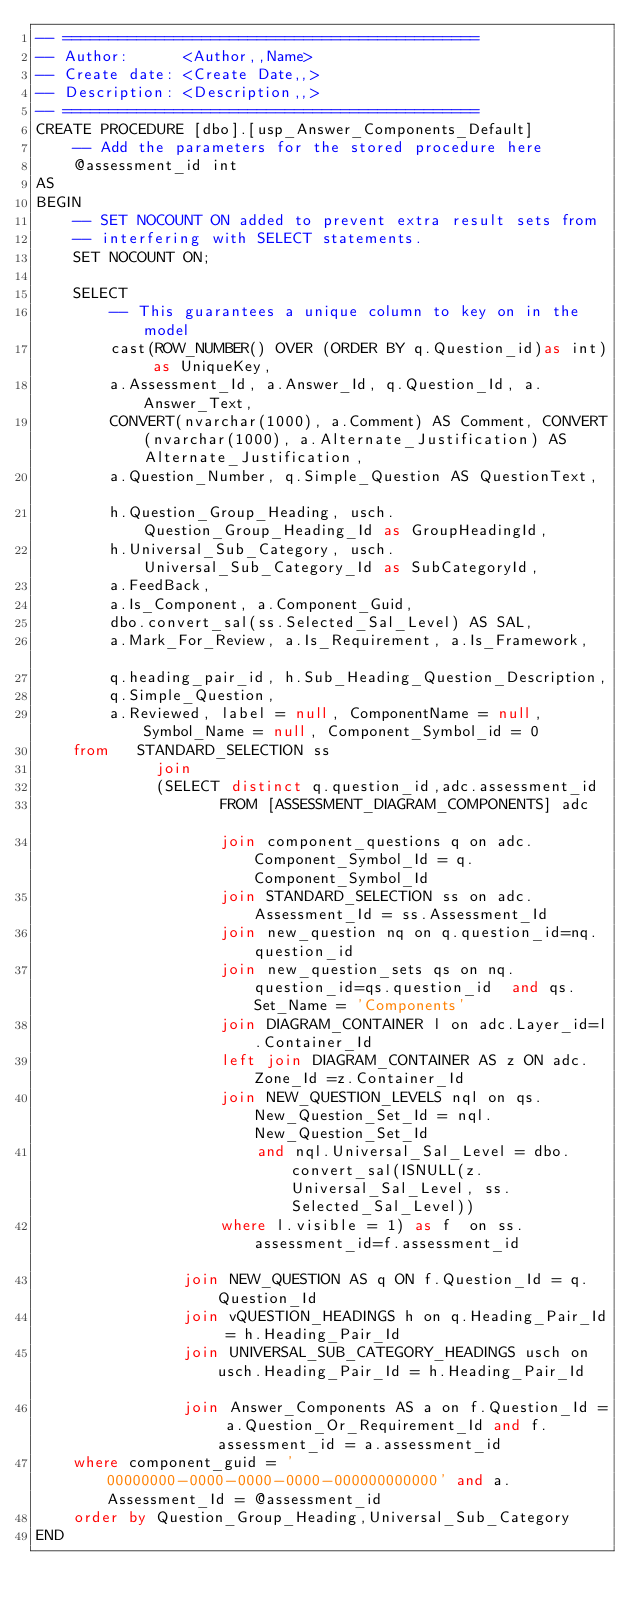Convert code to text. <code><loc_0><loc_0><loc_500><loc_500><_SQL_>-- =============================================
-- Author:		<Author,,Name>
-- Create date: <Create Date,,>
-- Description:	<Description,,>
-- =============================================
CREATE PROCEDURE [dbo].[usp_Answer_Components_Default]
	-- Add the parameters for the stored procedure here
	@assessment_id int
AS
BEGIN
	-- SET NOCOUNT ON added to prevent extra result sets from
	-- interfering with SELECT statements.
	SET NOCOUNT ON;

    SELECT                   
		-- This guarantees a unique column to key on in the model
		cast(ROW_NUMBER() OVER (ORDER BY q.Question_id)as int) as UniqueKey,
		a.Assessment_Id, a.Answer_Id, q.Question_Id, a.Answer_Text, 
		CONVERT(nvarchar(1000), a.Comment) AS Comment, CONVERT(nvarchar(1000), a.Alternate_Justification) AS Alternate_Justification, 
		a.Question_Number, q.Simple_Question AS QuestionText, 		
		h.Question_Group_Heading, usch.Question_Group_Heading_Id as GroupHeadingId, 
		h.Universal_Sub_Category, usch.Universal_Sub_Category_Id as SubCategoryId,
		a.FeedBack,
		a.Is_Component, a.Component_Guid, 
		dbo.convert_sal(ss.Selected_Sal_Level) AS SAL, 
		a.Mark_For_Review, a.Is_Requirement, a.Is_Framework,	
		q.heading_pair_id, h.Sub_Heading_Question_Description,
		q.Simple_Question, 
		a.Reviewed, label = null, ComponentName = null, Symbol_Name = null, Component_Symbol_id = 0
	from   STANDARD_SELECTION ss
			 join 
			 (SELECT distinct q.question_id,adc.assessment_id
					FROM [ASSESSMENT_DIAGRAM_COMPONENTS] adc 			
					join component_questions q on adc.Component_Symbol_Id = q.Component_Symbol_Id
					join STANDARD_SELECTION ss on adc.Assessment_Id = ss.Assessment_Id
					join new_question nq on q.question_id=nq.question_id		
					join new_question_sets qs on nq.question_id=qs.question_id	and qs.Set_Name = 'Components'		
					join DIAGRAM_CONTAINER l on adc.Layer_id=l.Container_Id
					left join DIAGRAM_CONTAINER AS z ON adc.Zone_Id =z.Container_Id
					join NEW_QUESTION_LEVELS nql on qs.New_Question_Set_Id = nql.New_Question_Set_Id 
						and nql.Universal_Sal_Level = dbo.convert_sal(ISNULL(z.Universal_Sal_Level, ss.Selected_Sal_Level))
					where l.visible = 1) as f  on ss.assessment_id=f.assessment_id							
				join NEW_QUESTION AS q ON f.Question_Id = q.Question_Id 
				join vQUESTION_HEADINGS h on q.Heading_Pair_Id = h.Heading_Pair_Id	
				join UNIVERSAL_SUB_CATEGORY_HEADINGS usch on usch.Heading_Pair_Id = h.Heading_Pair_Id		    
				join Answer_Components AS a on f.Question_Id = a.Question_Or_Requirement_Id and f.assessment_id = a.assessment_id	  
	where component_guid = '00000000-0000-0000-0000-000000000000' and a.Assessment_Id = @assessment_id
	order by Question_Group_Heading,Universal_Sub_Category
END
</code> 